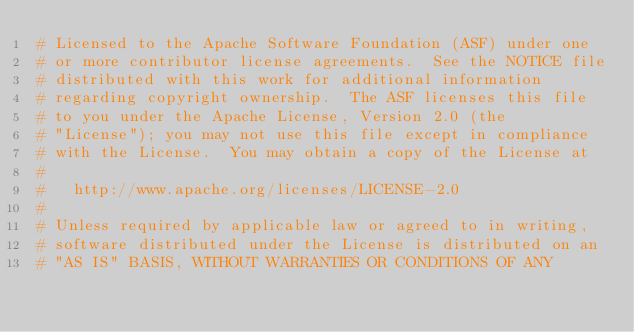<code> <loc_0><loc_0><loc_500><loc_500><_Python_># Licensed to the Apache Software Foundation (ASF) under one
# or more contributor license agreements.  See the NOTICE file
# distributed with this work for additional information
# regarding copyright ownership.  The ASF licenses this file
# to you under the Apache License, Version 2.0 (the
# "License"); you may not use this file except in compliance
# with the License.  You may obtain a copy of the License at
#
#   http://www.apache.org/licenses/LICENSE-2.0
#
# Unless required by applicable law or agreed to in writing,
# software distributed under the License is distributed on an
# "AS IS" BASIS, WITHOUT WARRANTIES OR CONDITIONS OF ANY</code> 